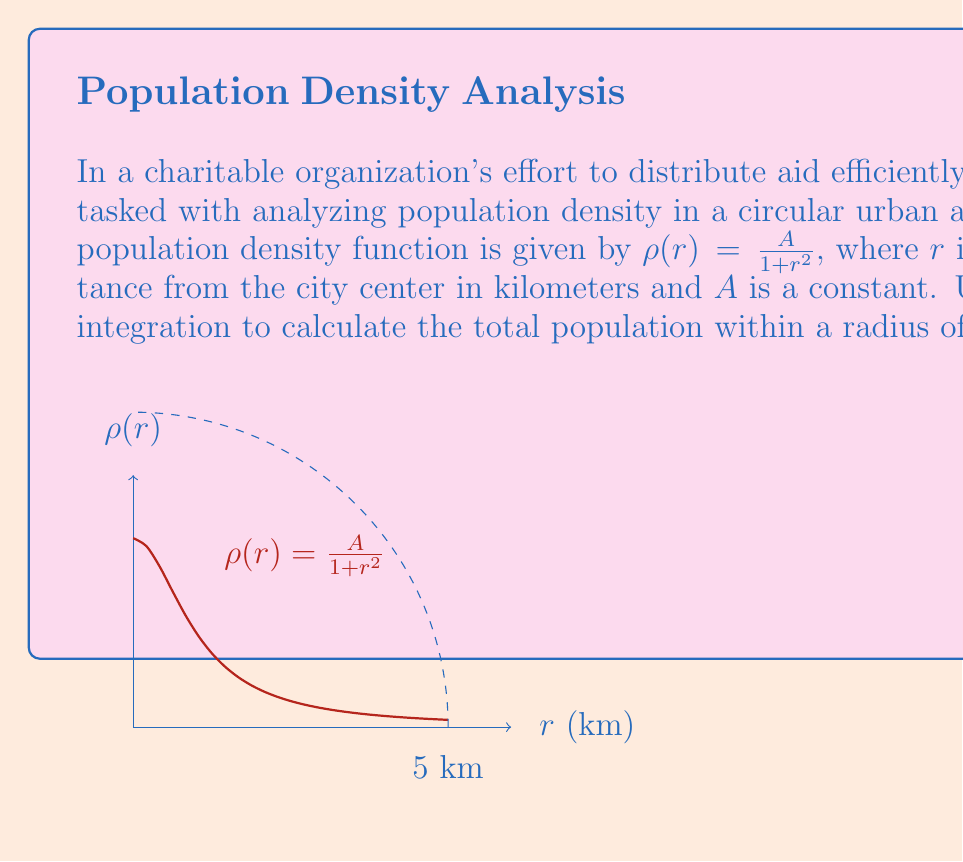Show me your answer to this math problem. To solve this problem using contour integration, we'll follow these steps:

1) The total population is given by the double integral:
   $$P = \int_0^{2\pi} \int_0^5 \rho(r) r dr d\theta = 2\pi A \int_0^5 \frac{r}{1+r^2} dr$$

2) To evaluate this using contour integration, we'll consider the complex function:
   $$f(z) = \frac{z}{1+z^2}$$

3) We'll integrate this function along a semicircular contour in the upper half-plane:
   $$\oint_C f(z) dz = \int_{-5}^5 f(x) dx + \int_\gamma f(z) dz$$
   where $\gamma$ is the semicircle from 5 to -5 in the upper half-plane.

4) By the residue theorem:
   $$\oint_C f(z) dz = 2\pi i \cdot \text{Res}(f, i)$$

5) The residue at $z=i$ is:
   $$\text{Res}(f, i) = \lim_{z \to i} (z-i)\frac{z}{1+z^2} = \frac{i}{2i} = \frac{1}{2}$$

6) Therefore:
   $$\oint_C f(z) dz = 2\pi i \cdot \frac{1}{2} = \pi i$$

7) As the radius of the semicircle approaches infinity, the integral along $\gamma$ approaches zero.

8) Thus:
   $$\int_{-5}^5 \frac{x}{1+x^2} dx = \pi i$$

9) The imaginary part cancels out, leaving:
   $$\int_0^5 \frac{r}{1+r^2} dr = \frac{\pi}{2}$$

10) Substituting back into our original equation:
    $$P = 2\pi A \cdot \frac{\pi}{2} = \pi^2 A$$

Therefore, the total population within a 5 km radius is $\pi^2 A$.
Answer: $\pi^2 A$ 